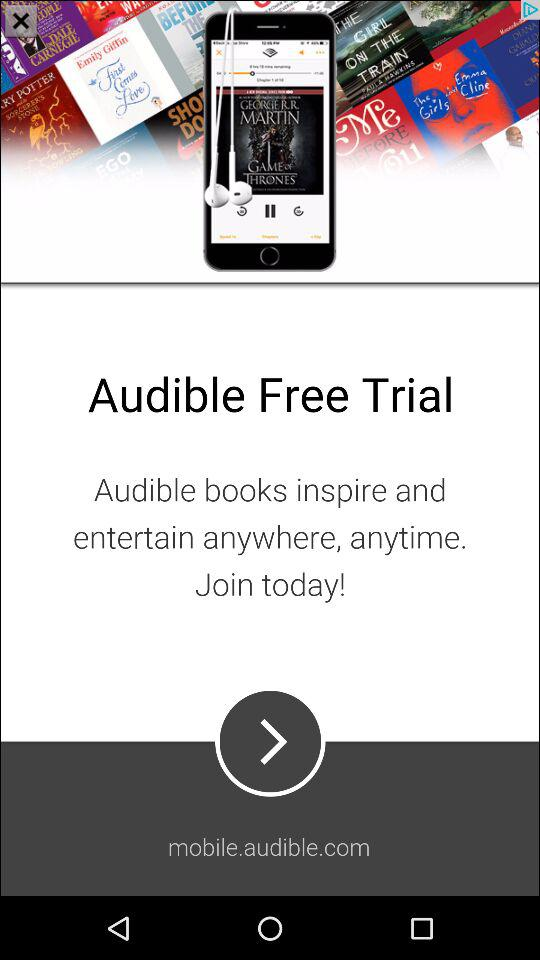What is the name of the application? The name of the application is "Audible". 